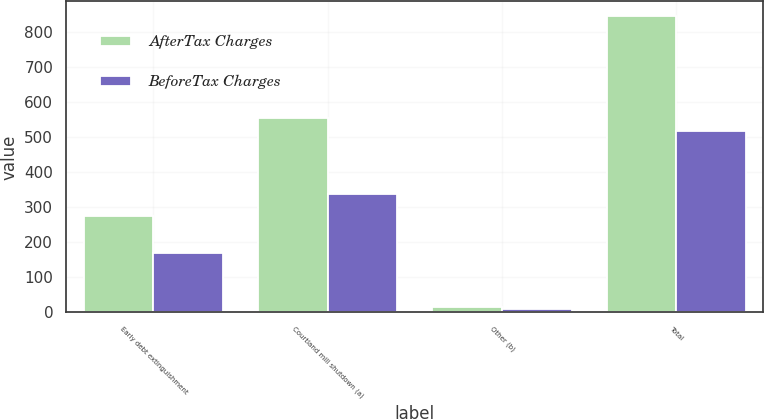<chart> <loc_0><loc_0><loc_500><loc_500><stacked_bar_chart><ecel><fcel>Early debt extinguishment<fcel>Courtland mill shutdown (a)<fcel>Other (b)<fcel>Total<nl><fcel>AfterTax Charges<fcel>276<fcel>554<fcel>16<fcel>846<nl><fcel>BeforeTax Charges<fcel>169<fcel>338<fcel>11<fcel>518<nl></chart> 